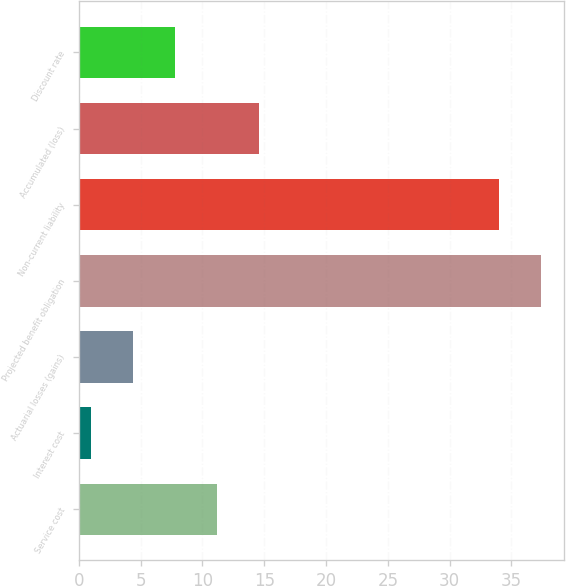Convert chart. <chart><loc_0><loc_0><loc_500><loc_500><bar_chart><fcel>Service cost<fcel>Interest cost<fcel>Actuarial losses (gains)<fcel>Projected benefit obligation<fcel>Non-current liability<fcel>Accumulated (loss)<fcel>Discount rate<nl><fcel>11.2<fcel>1<fcel>4.4<fcel>37.4<fcel>34<fcel>14.6<fcel>7.8<nl></chart> 